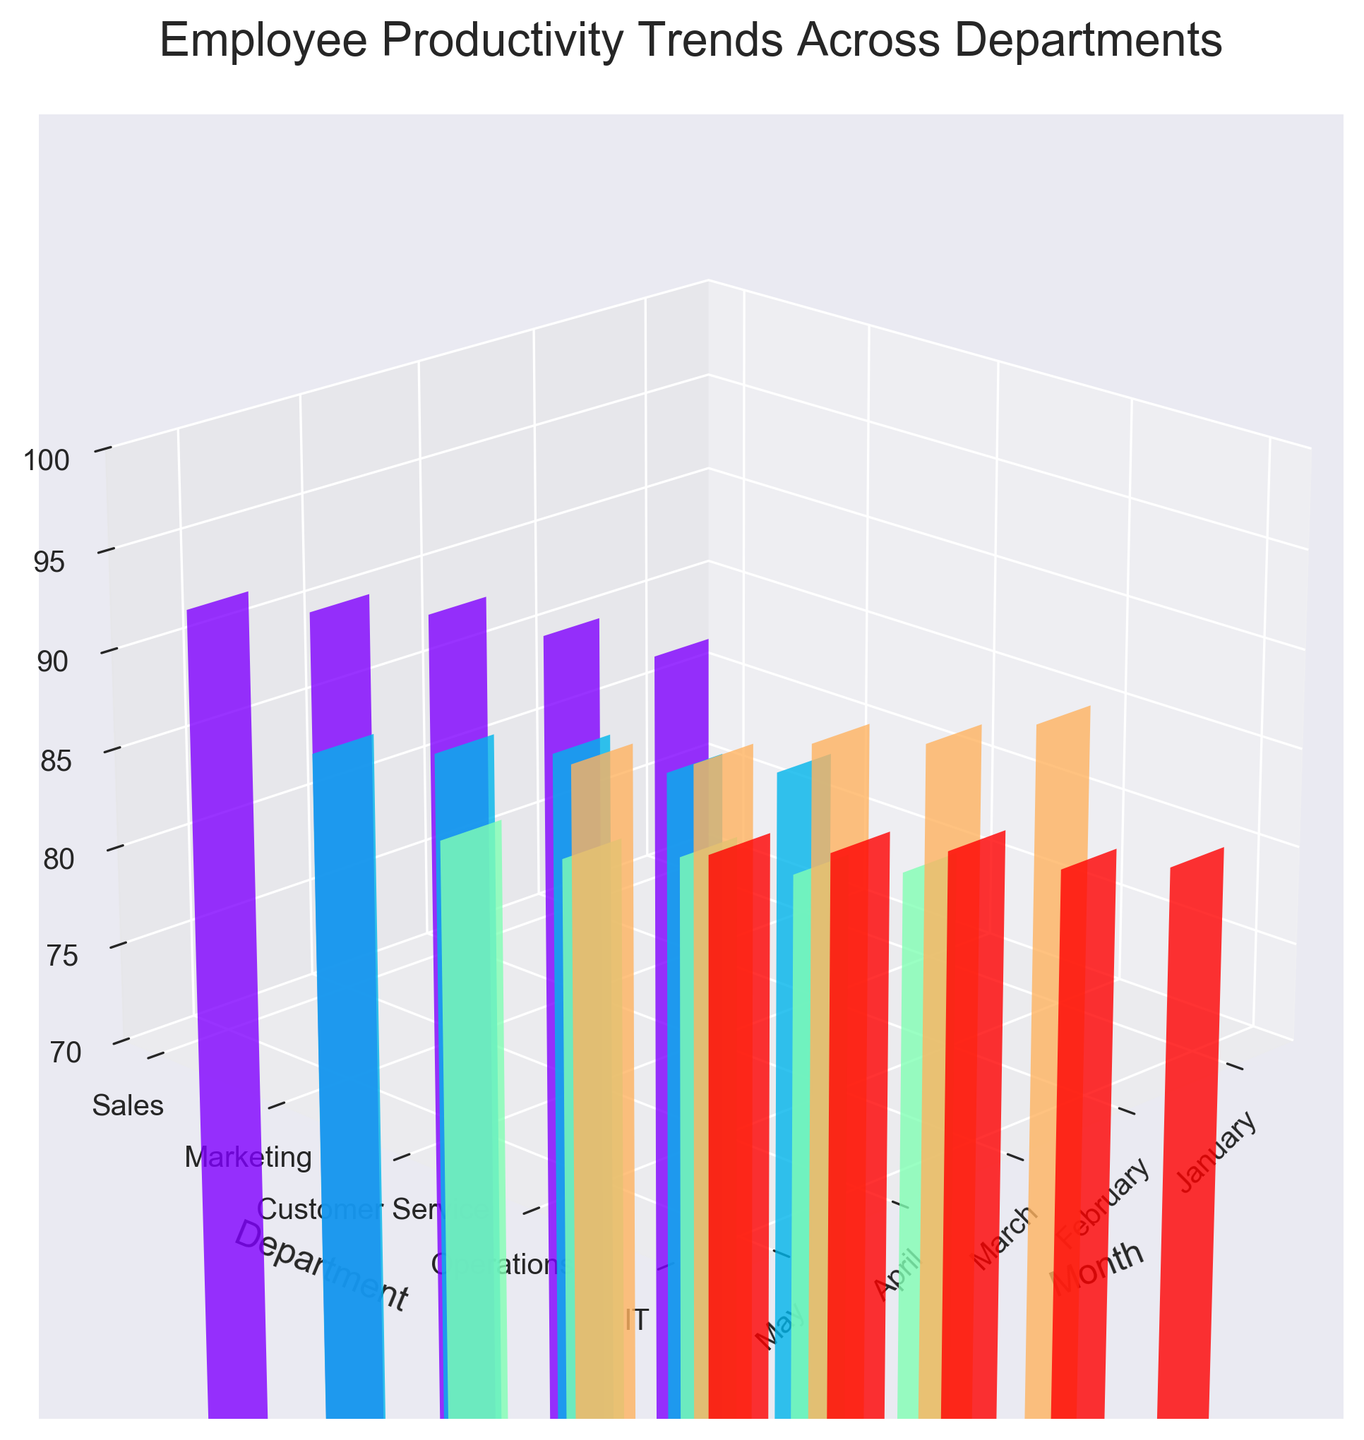What's the title of the plot? The title is displayed at the top of the plot. It provides a summary of what the plot is about.
Answer: Employee Productivity Trends Across Departments Which department has the highest productivity score in May? To determine the department with the highest productivity score in May, locate the bar for May in each department, and find the one that reaches the highest point on the z-axis.
Answer: Sales What is the range of productivity scores displayed on the z-axis? The range of z-axis values is given by its limits and these can be observed on the z-axis itself.
Answer: 70 to 100 Which department shows the most consistent increase in productivity scores over the months? To find the most consistent increase, look for the department with bars displaying a steady upward trend in height from January to May. A smooth, rising pattern indicates consistency.
Answer: Sales How does the productivity score of the IT department in April compare to that of Marketing in the same month? Check the heights of the bars for IT and Marketing in April. Compare their respective positions on the z-axis to see which is higher.
Answer: Higher What is the average productivity score for Customer Service from January to May? Sum the productivity scores for Customer Service (75, 77, 80, 82, 85) and divide by the number of months (5).
Answer: 79.8 By how much did the Sales department's productivity score increase from January to May? Subtract the productivity score of Sales in January (82) from that in May (92).
Answer: 10 Which department had the lowest productivity score in January? Observe the heights of the bars for all departments in January and identify the lowest one.
Answer: Customer Service Is there any department that shows a decrease in productivity score in any month from January to May? Inspect the trend of the bars for each department individually, assessing if any bar declines in comparison to the previous month.
Answer: No, all departments show an increase 